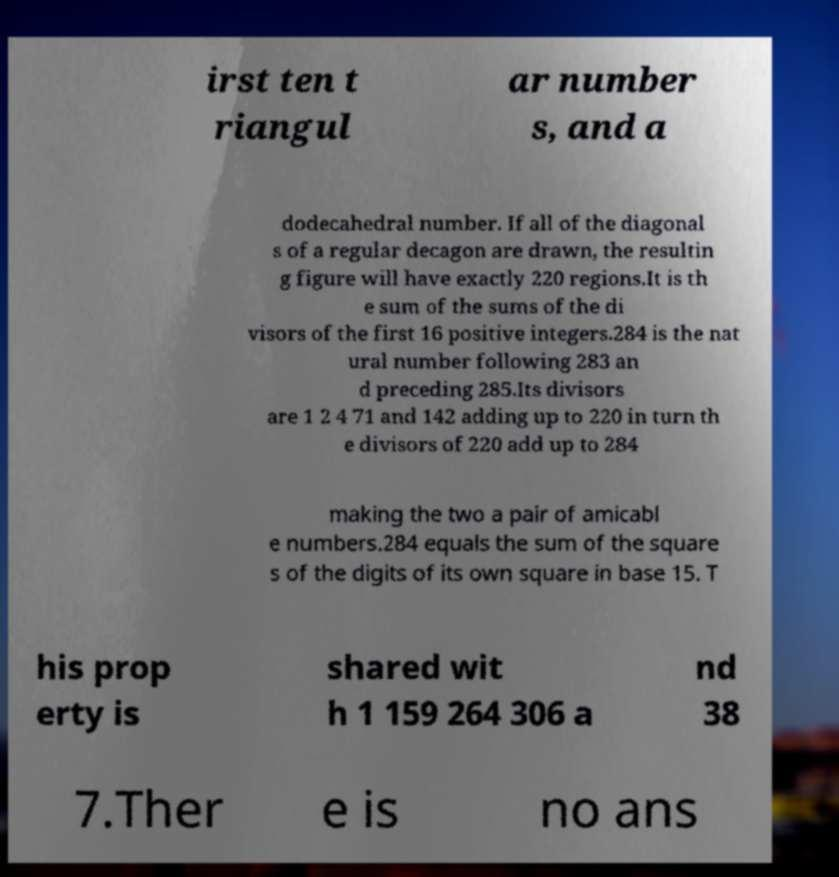I need the written content from this picture converted into text. Can you do that? irst ten t riangul ar number s, and a dodecahedral number. If all of the diagonal s of a regular decagon are drawn, the resultin g figure will have exactly 220 regions.It is th e sum of the sums of the di visors of the first 16 positive integers.284 is the nat ural number following 283 an d preceding 285.Its divisors are 1 2 4 71 and 142 adding up to 220 in turn th e divisors of 220 add up to 284 making the two a pair of amicabl e numbers.284 equals the sum of the square s of the digits of its own square in base 15. T his prop erty is shared wit h 1 159 264 306 a nd 38 7.Ther e is no ans 